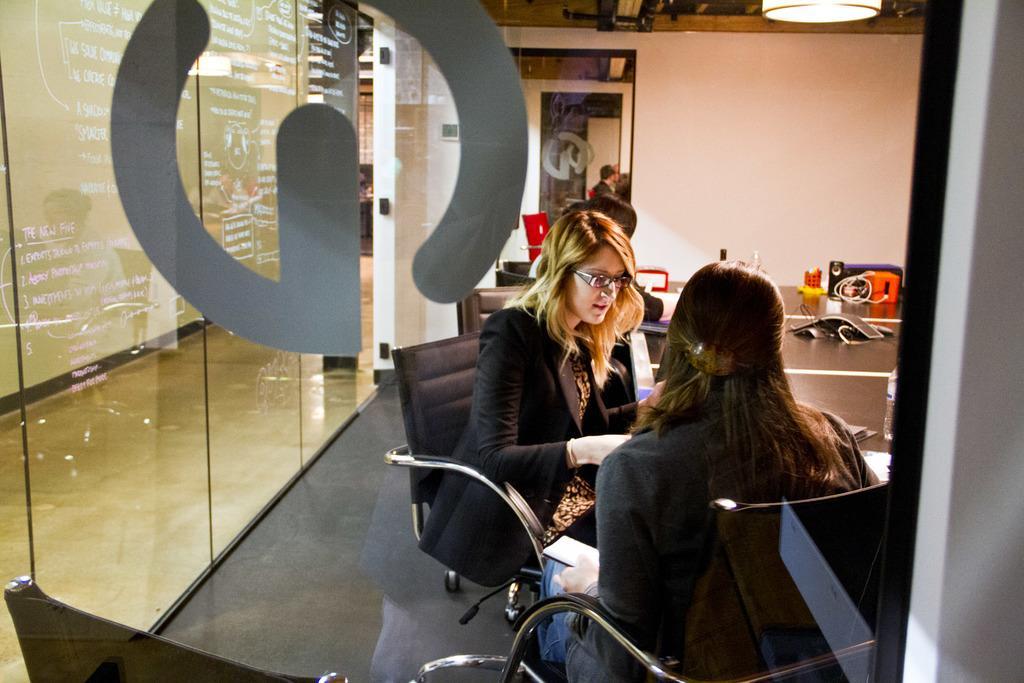In one or two sentences, can you explain what this image depicts? In the center of the image there are two persons sitting on chair. There is a glass at the left side of the image. 